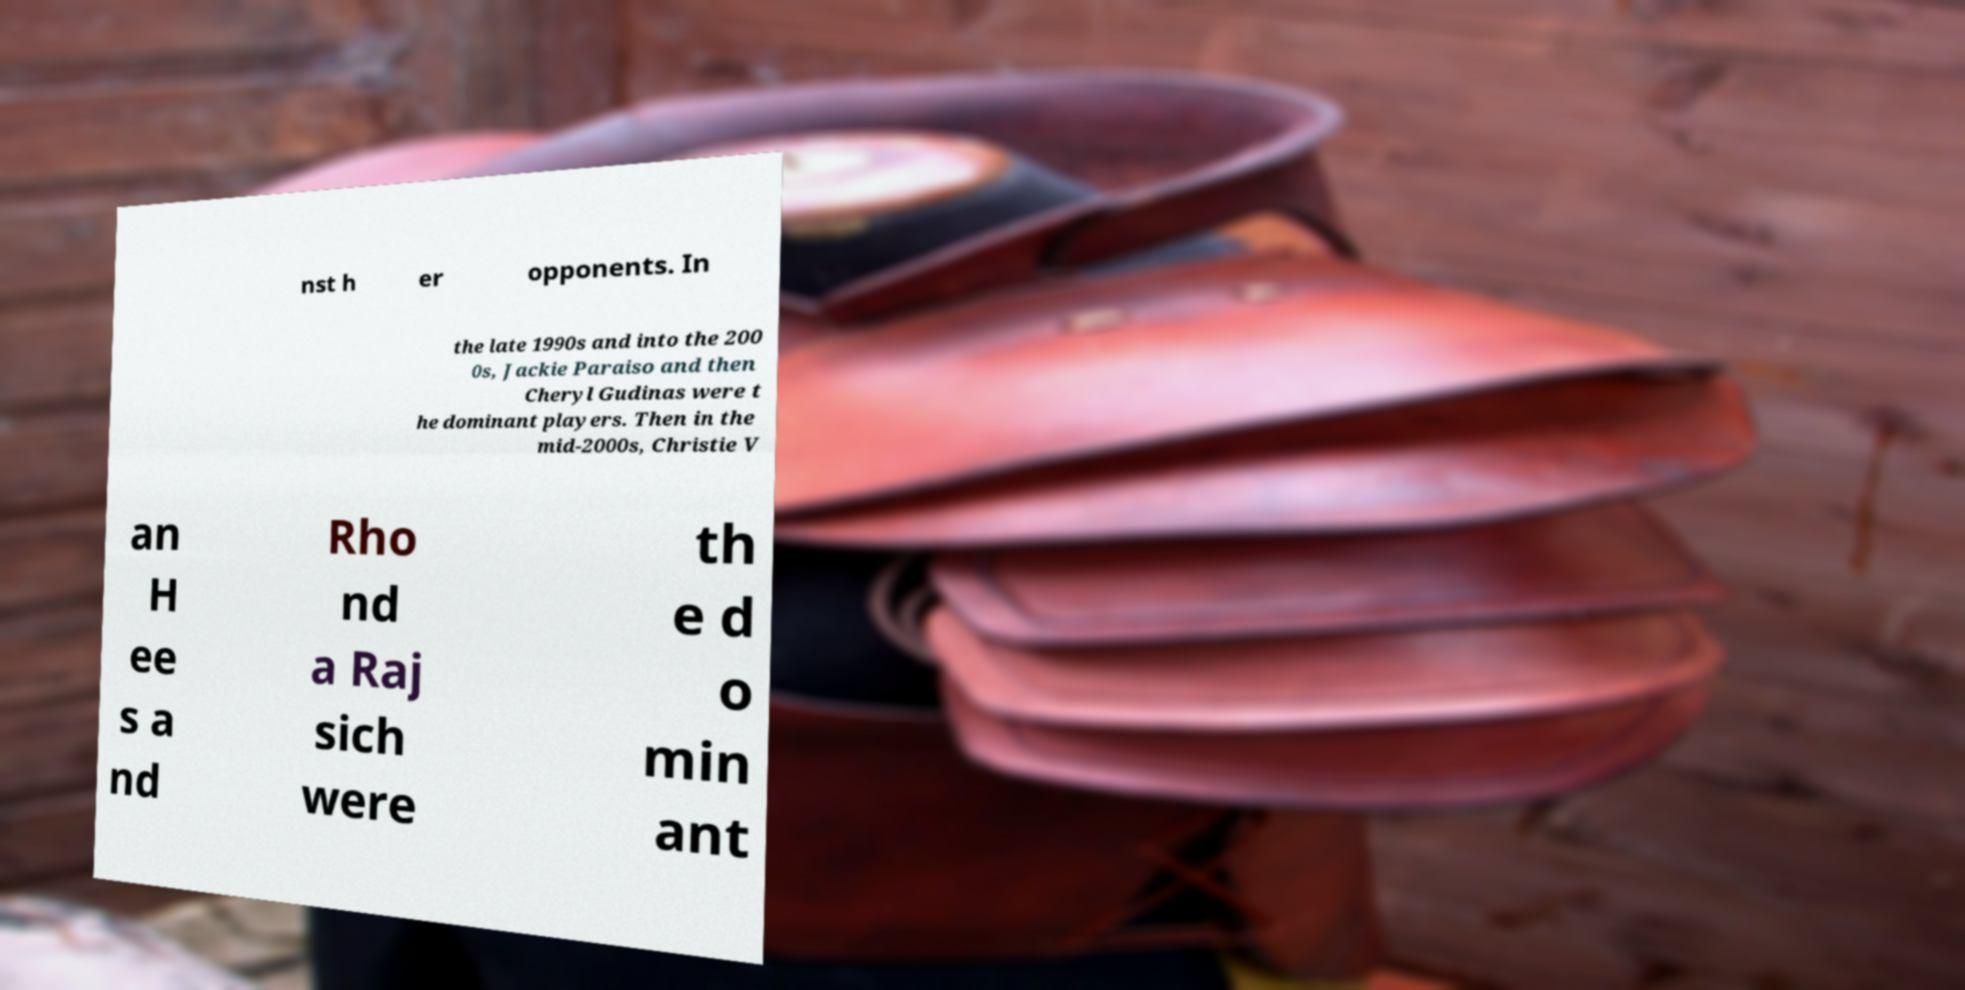Please read and relay the text visible in this image. What does it say? nst h er opponents. In the late 1990s and into the 200 0s, Jackie Paraiso and then Cheryl Gudinas were t he dominant players. Then in the mid-2000s, Christie V an H ee s a nd Rho nd a Raj sich were th e d o min ant 